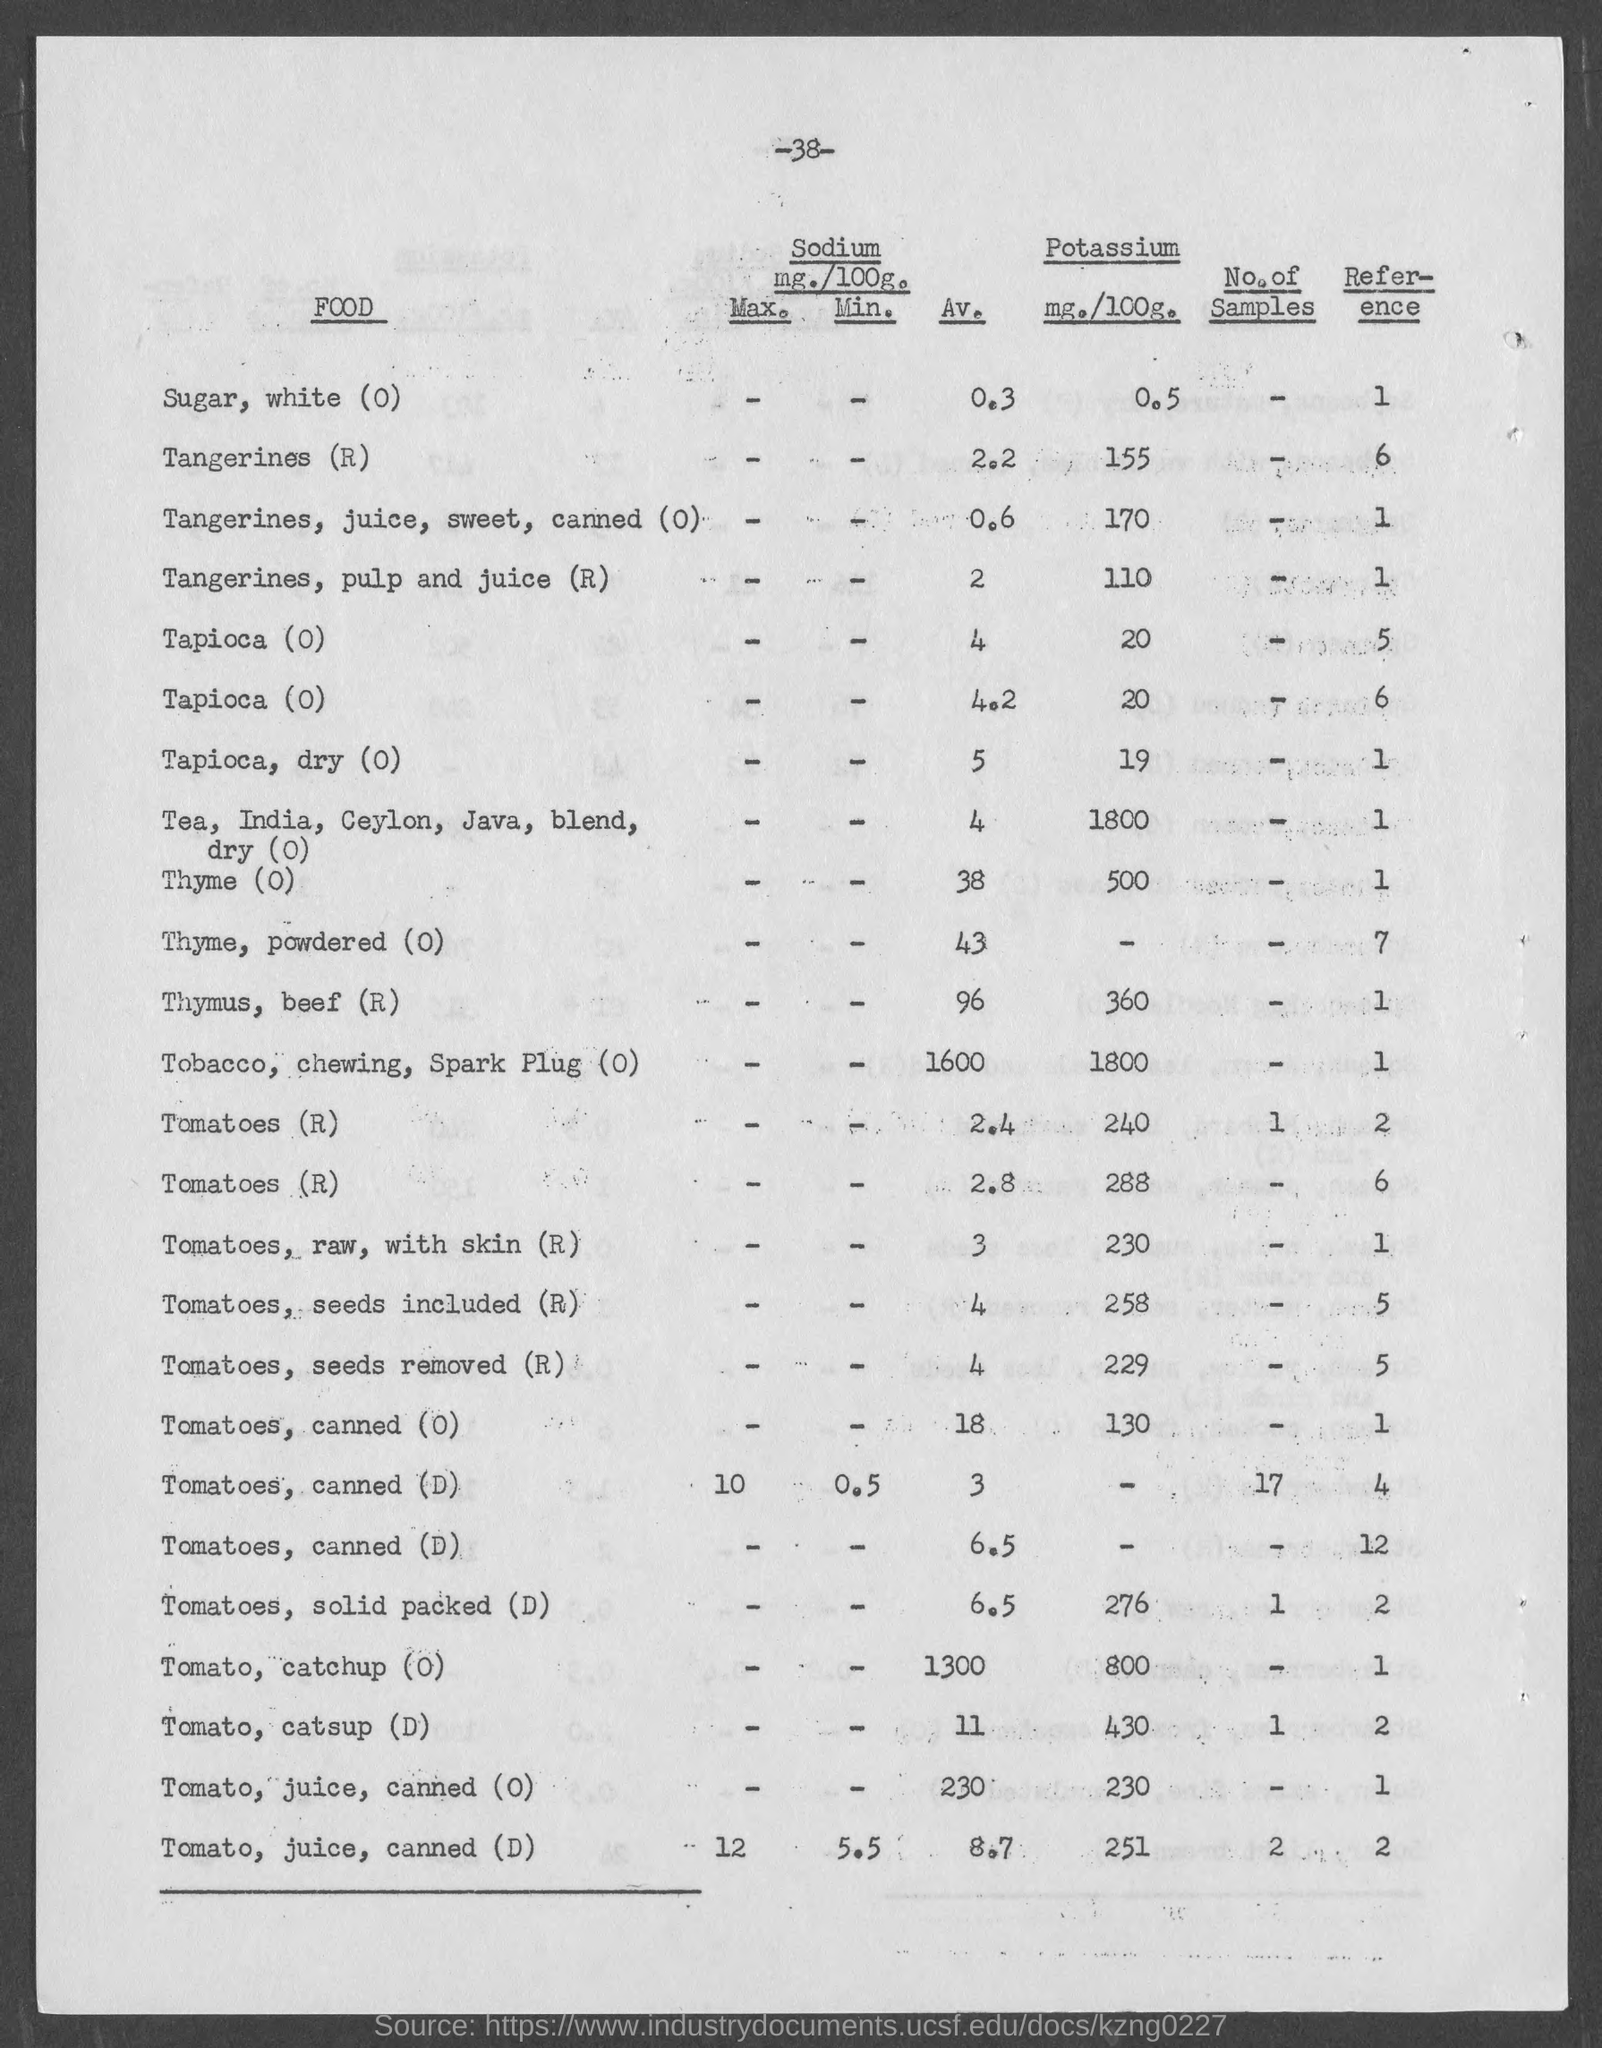Draw attention to some important aspects in this diagram. The reference given for Thyme, powdered (0) is 7. The page number mentioned in this document is 38. The average amount of sodium present in tangerines is approximately 2.2 milligrams per 100 grams. The average amount of sodium (milligrams per 100 grams) in thyme is not available as 0 grams of thyme was not provided. However, the range of sodium content in thyme is between 200-500 milligrams per 100 grams. The amount of potassium present in canned tomatoes is not specified. 